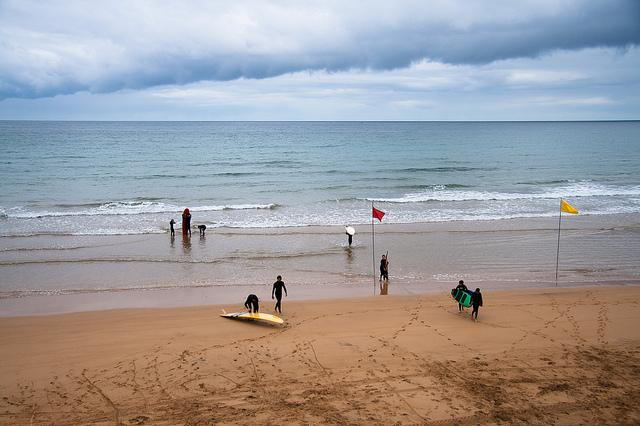What does the red flag mean? Please explain your reasoning. swimming prohibited. Flags like this are used to bring peoples attention to some danger they should be aware of. at a beach a warning flag near the water is likely warning people not to swim. 